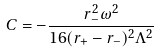<formula> <loc_0><loc_0><loc_500><loc_500>C = - \frac { r _ { - } ^ { 2 } \omega ^ { 2 } } { 1 6 ( r _ { + } - r _ { - } ) ^ { 2 } \Lambda ^ { 2 } }</formula> 